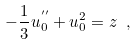<formula> <loc_0><loc_0><loc_500><loc_500>\label l { e q \colon p a i n l e v e I } - \frac { 1 } { 3 } u _ { 0 } ^ { ^ { \prime \prime } } + u _ { 0 } ^ { 2 } = z \ ,</formula> 